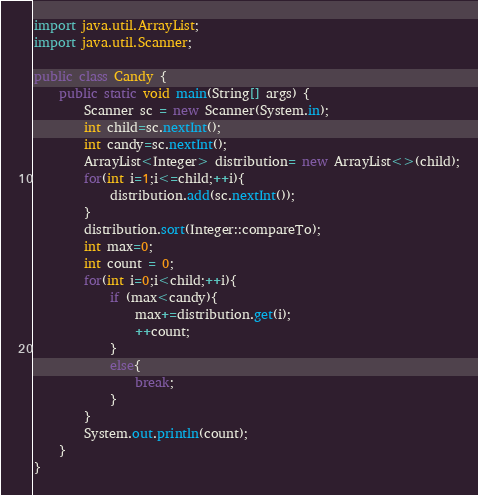<code> <loc_0><loc_0><loc_500><loc_500><_Java_>import java.util.ArrayList;
import java.util.Scanner;

public class Candy {
    public static void main(String[] args) {
        Scanner sc = new Scanner(System.in);
        int child=sc.nextInt();
        int candy=sc.nextInt();
        ArrayList<Integer> distribution= new ArrayList<>(child);
        for(int i=1;i<=child;++i){
            distribution.add(sc.nextInt());
        }
        distribution.sort(Integer::compareTo);
        int max=0;
        int count = 0;
        for(int i=0;i<child;++i){
            if (max<candy){
                max+=distribution.get(i);
                ++count;
            }
            else{
                break;
            }
        }
        System.out.println(count);
    }
}
</code> 